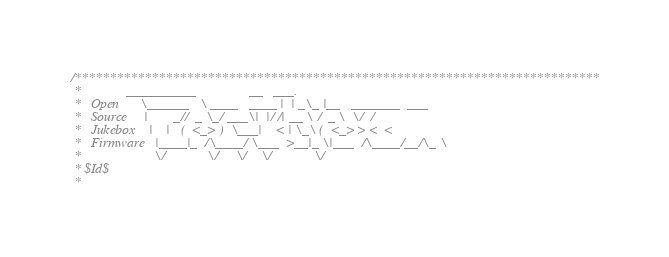Convert code to text. <code><loc_0><loc_0><loc_500><loc_500><_C_>/***************************************************************************
 *             __________               __   ___.
 *   Open      \______   \ ____   ____ |  | _\_ |__   _______  ___
 *   Source     |       _//  _ \_/ ___\|  |/ /| __ \ /  _ \  \/  /
 *   Jukebox    |    |   (  <_> )  \___|    < | \_\ (  <_> > <  <
 *   Firmware   |____|_  /\____/ \___  >__|_ \|___  /\____/__/\_ \
 *                     \/            \/     \/    \/            \/
 * $Id$
 *</code> 